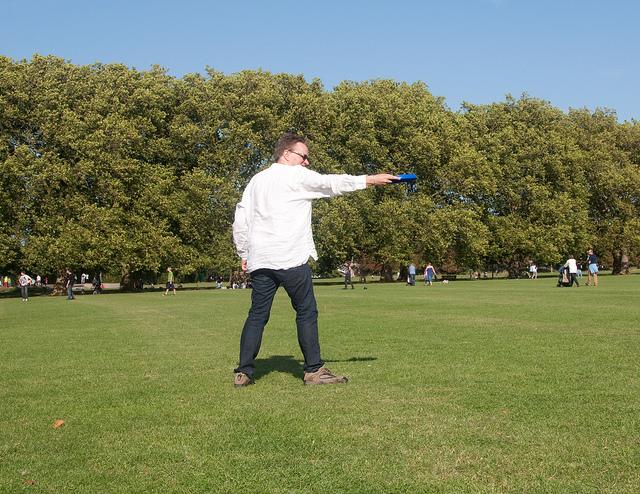Is the man unpleasant?
Write a very short answer. No. What sport does he play?
Concise answer only. Frisbee. What is the color of the frisbee?
Be succinct. Blue. What type of pants are the men wearing?
Concise answer only. Jeans. Is the man wearing tennis shoes?
Quick response, please. No. Is the man wearing a hat?
Write a very short answer. No. What color is the hitters shirt?
Give a very brief answer. White. What is he throwing?
Answer briefly. Frisbee. 